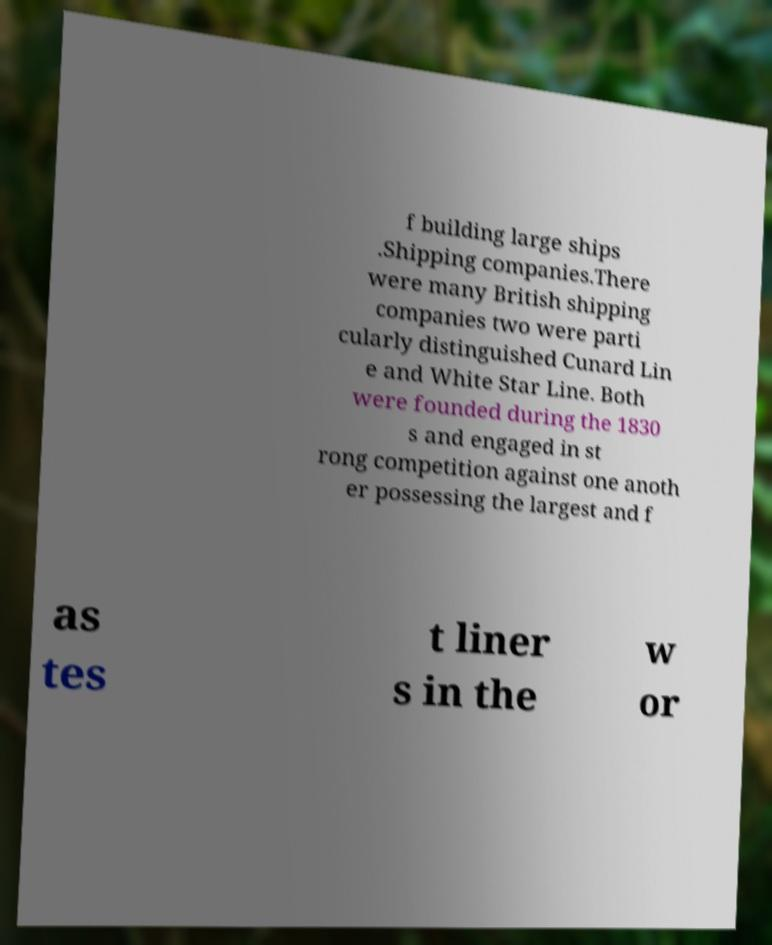Can you read and provide the text displayed in the image?This photo seems to have some interesting text. Can you extract and type it out for me? f building large ships .Shipping companies.There were many British shipping companies two were parti cularly distinguished Cunard Lin e and White Star Line. Both were founded during the 1830 s and engaged in st rong competition against one anoth er possessing the largest and f as tes t liner s in the w or 